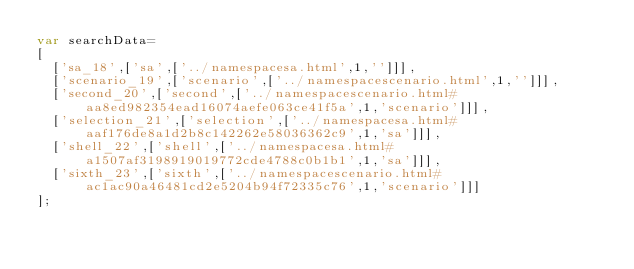Convert code to text. <code><loc_0><loc_0><loc_500><loc_500><_JavaScript_>var searchData=
[
  ['sa_18',['sa',['../namespacesa.html',1,'']]],
  ['scenario_19',['scenario',['../namespacescenario.html',1,'']]],
  ['second_20',['second',['../namespacescenario.html#aa8ed982354ead16074aefe063ce41f5a',1,'scenario']]],
  ['selection_21',['selection',['../namespacesa.html#aaf176de8a1d2b8c142262e58036362c9',1,'sa']]],
  ['shell_22',['shell',['../namespacesa.html#a1507af3198919019772cde4788c0b1b1',1,'sa']]],
  ['sixth_23',['sixth',['../namespacescenario.html#ac1ac90a46481cd2e5204b94f72335c76',1,'scenario']]]
];
</code> 